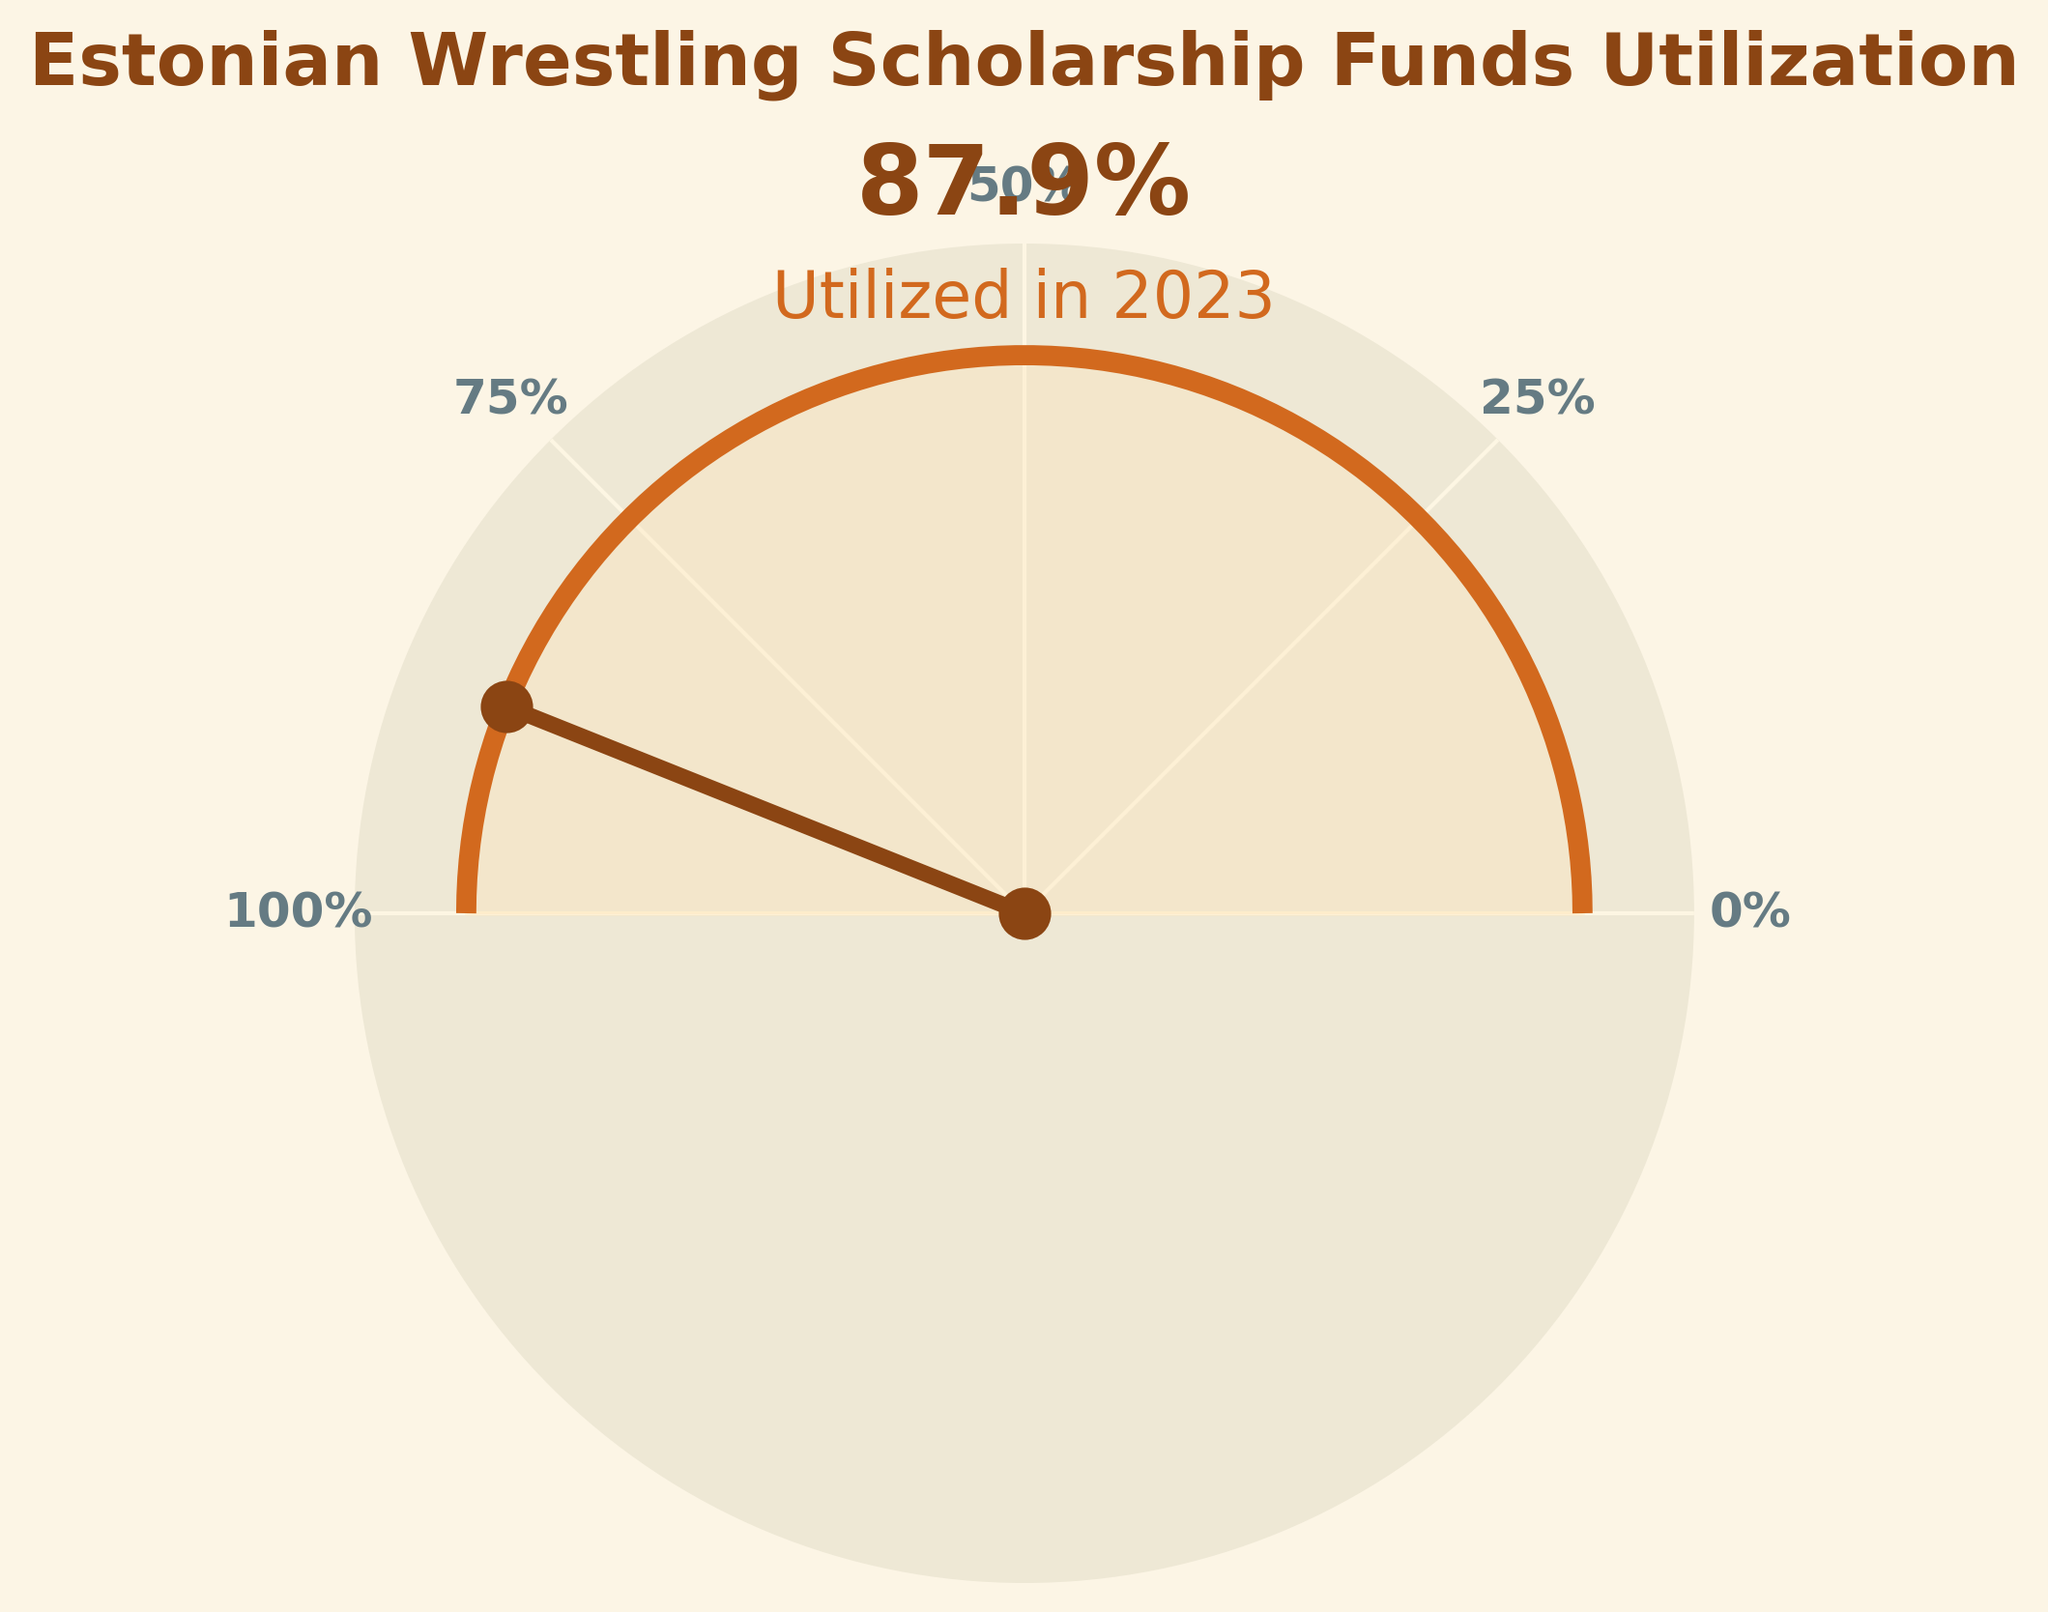How much percentage of Estonian wrestling scholarship funds was utilized in 2023? The figure has a labeled value of 87.9% for the year 2023.
Answer: 87.9% What is the title of the chart? The title is shown at the top of the figure in bold. It reads: "Estonian Wrestling Scholarship Funds Utilization".
Answer: Estonian Wrestling Scholarship Funds Utilization What is the maximum percentage utilization displayed on the chart? The maximum percentage utilization, shown as a data point and marked on the gauge, is for the year 2022 with 91.3%.
Answer: 91.3% Which year had the lowest utilization of scholarship funds, and what was the percentage? By observing the values for each year, 2020 had the lowest utilization with 65.2%.
Answer: 2020, 65.2% From 2019 to 2023, which year showed the most significant year-to-year increase in fund utilization, and by how much? The most significant year-to-year increase is between 2020 to 2021. The increase is 82.7% - 65.2% = 17.5%.
Answer: 2021, 17.5% On the gauge, what is the percentage value represented by the needle's position? The needle's position corresponds to the year 2023 and points to 87.9%.
Answer: 87.9% What is the average percentage utilization of the funds over the five years displayed? Adding the percentage values and dividing by the number of years: (78.5 + 65.2 + 82.7 + 91.3 + 87.9)/5 = 405.6/5 = 81.12%.
Answer: 81.12% What color is used to fill the area under the gauge arc, and what is its opacity? The area under the arc is filled with a light tan color with a 30% opacity.
Answer: Light tan, 30% How does the utilization percentage in 2023 compare to the previous year, 2022? The utilization percentage in 2023 (87.9%) is slightly lower than in 2022 (91.3%).
Answer: Slightly lower What labels are given to the ticks on the x-axis of the gauge chart? The ticks on the x-axis of the gauge chart are labeled 0%, 25%, 50%, 75%, and 100%.
Answer: 0%, 25%, 50%, 75%, 100% 